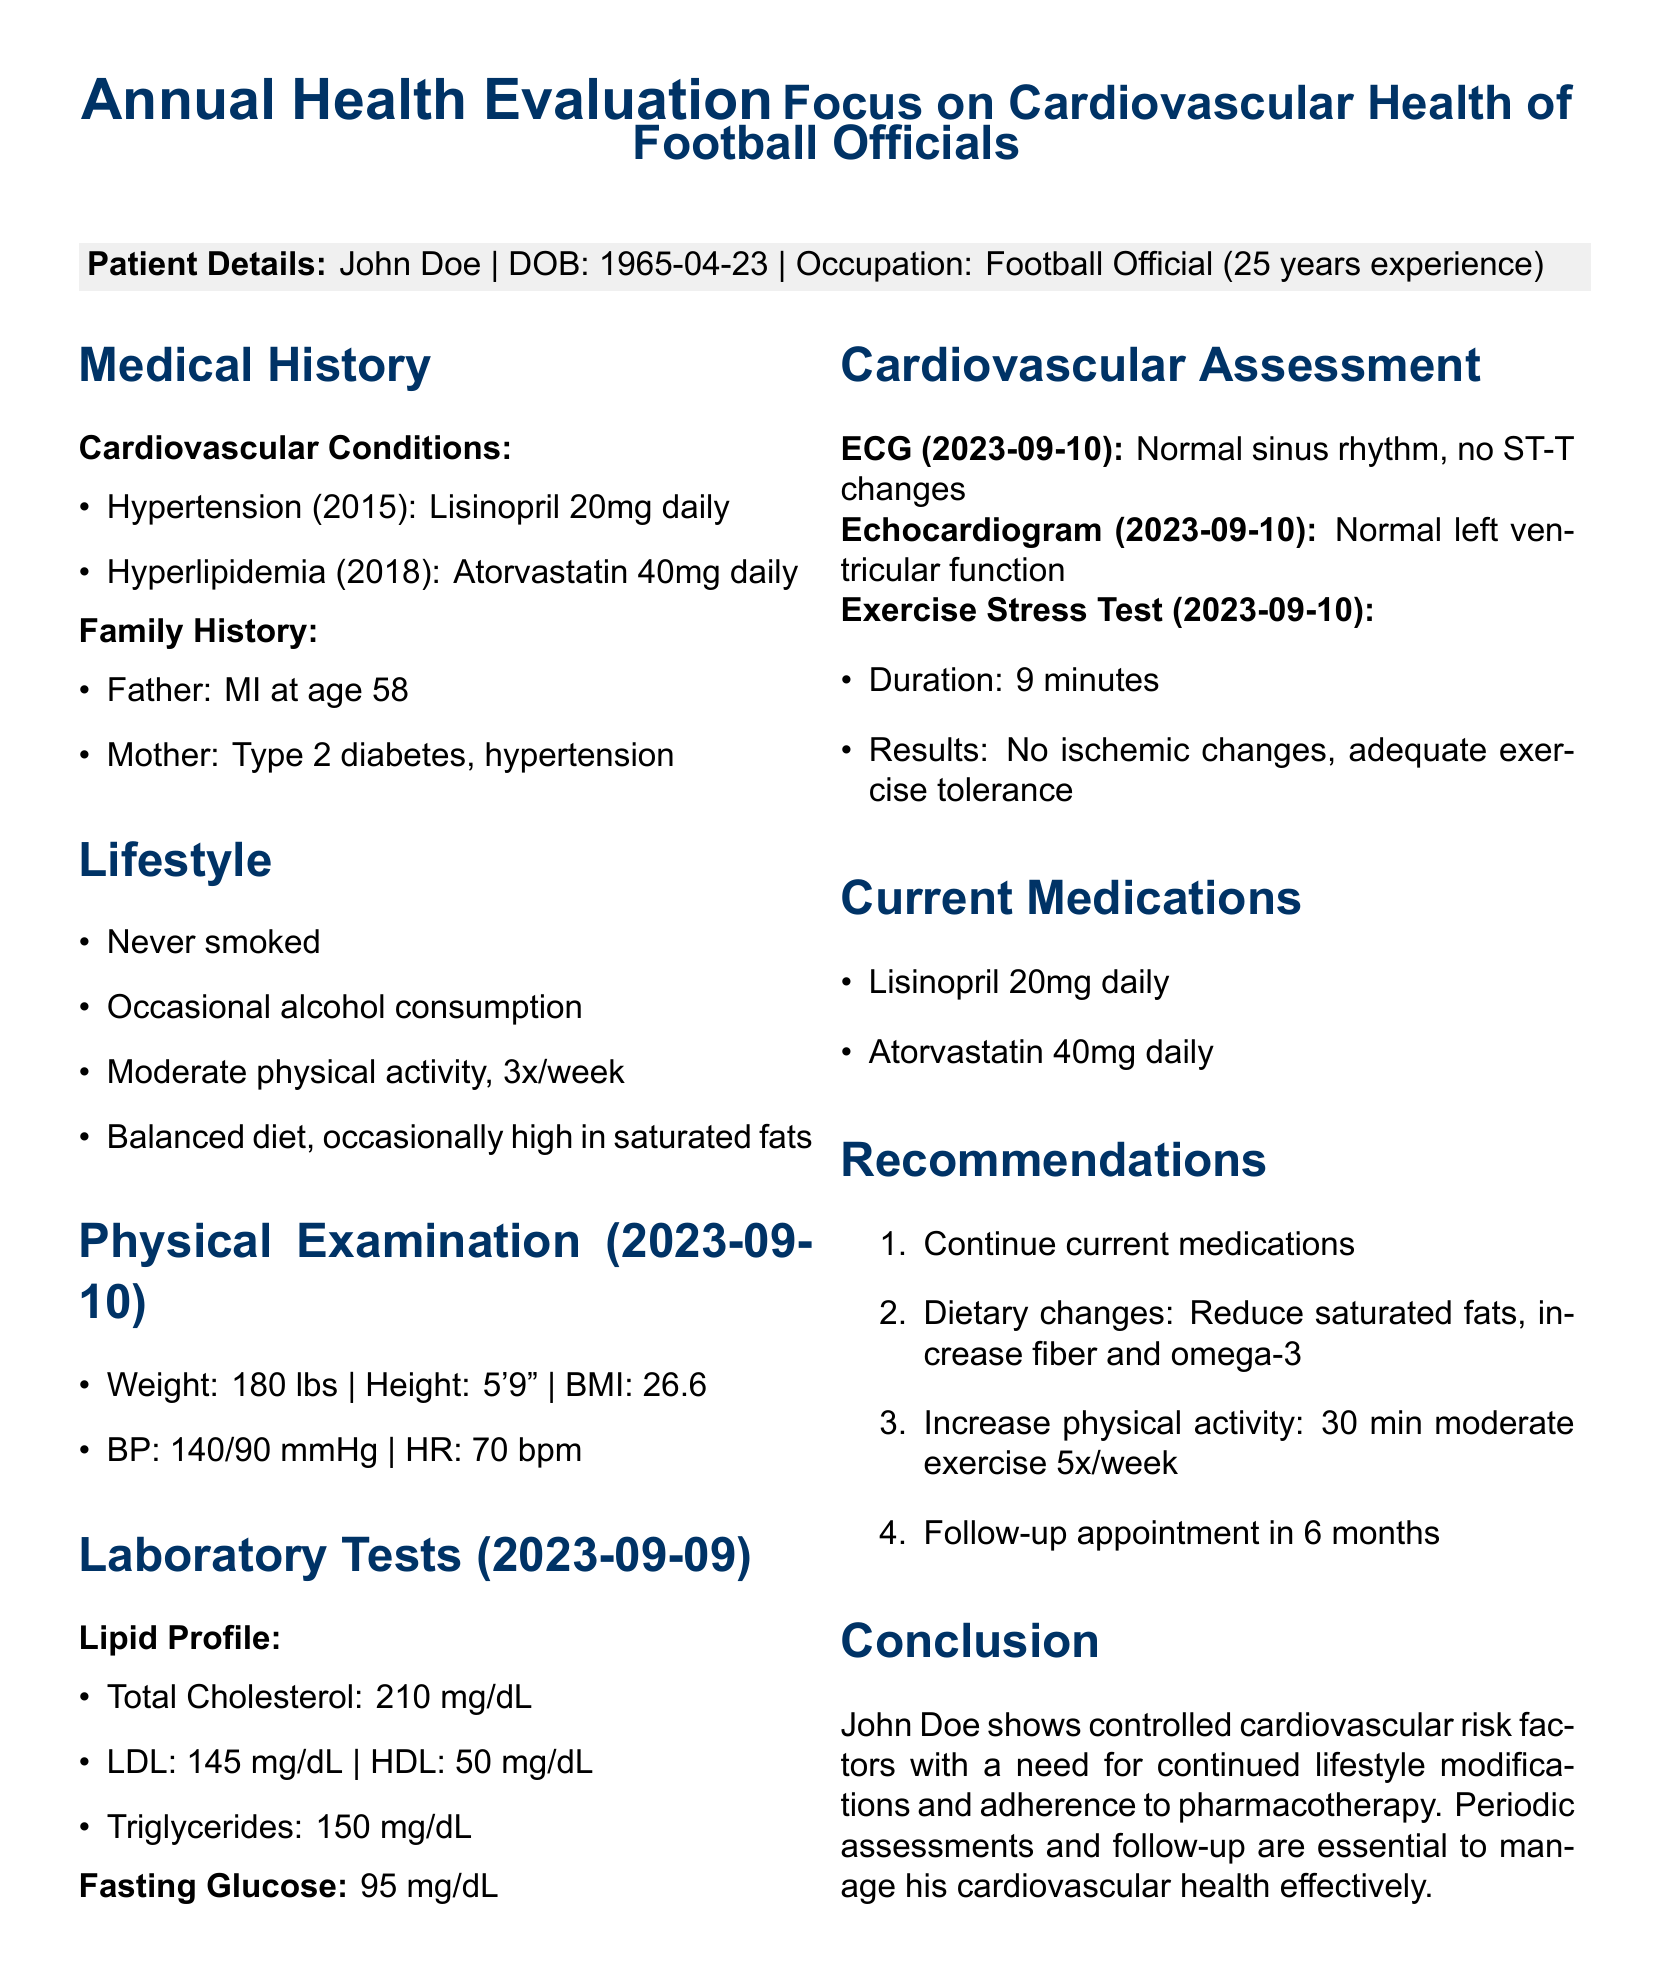What is the patient's name? The patient's name is presented in the Patient Details section of the document.
Answer: John Doe When was the patient born? The date of birth is included in the Patient Details section of the document.
Answer: 1965-04-23 What medication is prescribed for hypertension? The medication for hypertension is indicated in the Medical History section.
Answer: Lisinopril 20mg daily What was the patient's weight during the physical examination? The patient's weight is provided in the Physical Examination section.
Answer: 180 lbs What is the HDL level from the lipid profile? The HDL level is listed in the Laboratory Tests section under Lipid Profile.
Answer: 50 mg/dL How many years of experience does the patient have as a football official? The years of experience is noted in the Patient Details section.
Answer: 25 years What dietary changes are recommended for the patient? The recommendations for dietary changes are specified in the Recommendations section.
Answer: Reduce saturated fats, increase fiber and omega-3 What was the duration of the exercise stress test? The duration of the exercise stress test is mentioned in the Cardiovascular Assessment section.
Answer: 9 minutes What is the follow-up appointment timeline? The follow-up appointment schedule is indicated in the Recommendations section.
Answer: in 6 months 